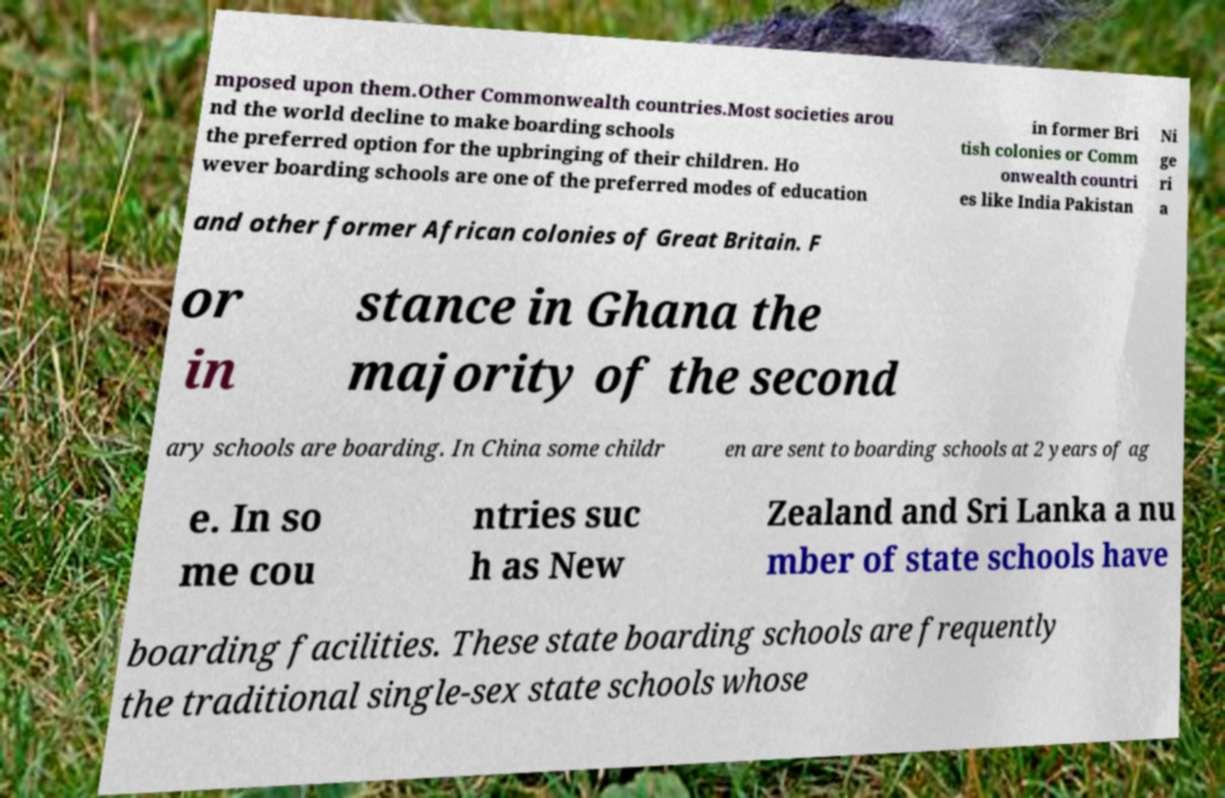Can you read and provide the text displayed in the image?This photo seems to have some interesting text. Can you extract and type it out for me? mposed upon them.Other Commonwealth countries.Most societies arou nd the world decline to make boarding schools the preferred option for the upbringing of their children. Ho wever boarding schools are one of the preferred modes of education in former Bri tish colonies or Comm onwealth countri es like India Pakistan Ni ge ri a and other former African colonies of Great Britain. F or in stance in Ghana the majority of the second ary schools are boarding. In China some childr en are sent to boarding schools at 2 years of ag e. In so me cou ntries suc h as New Zealand and Sri Lanka a nu mber of state schools have boarding facilities. These state boarding schools are frequently the traditional single-sex state schools whose 